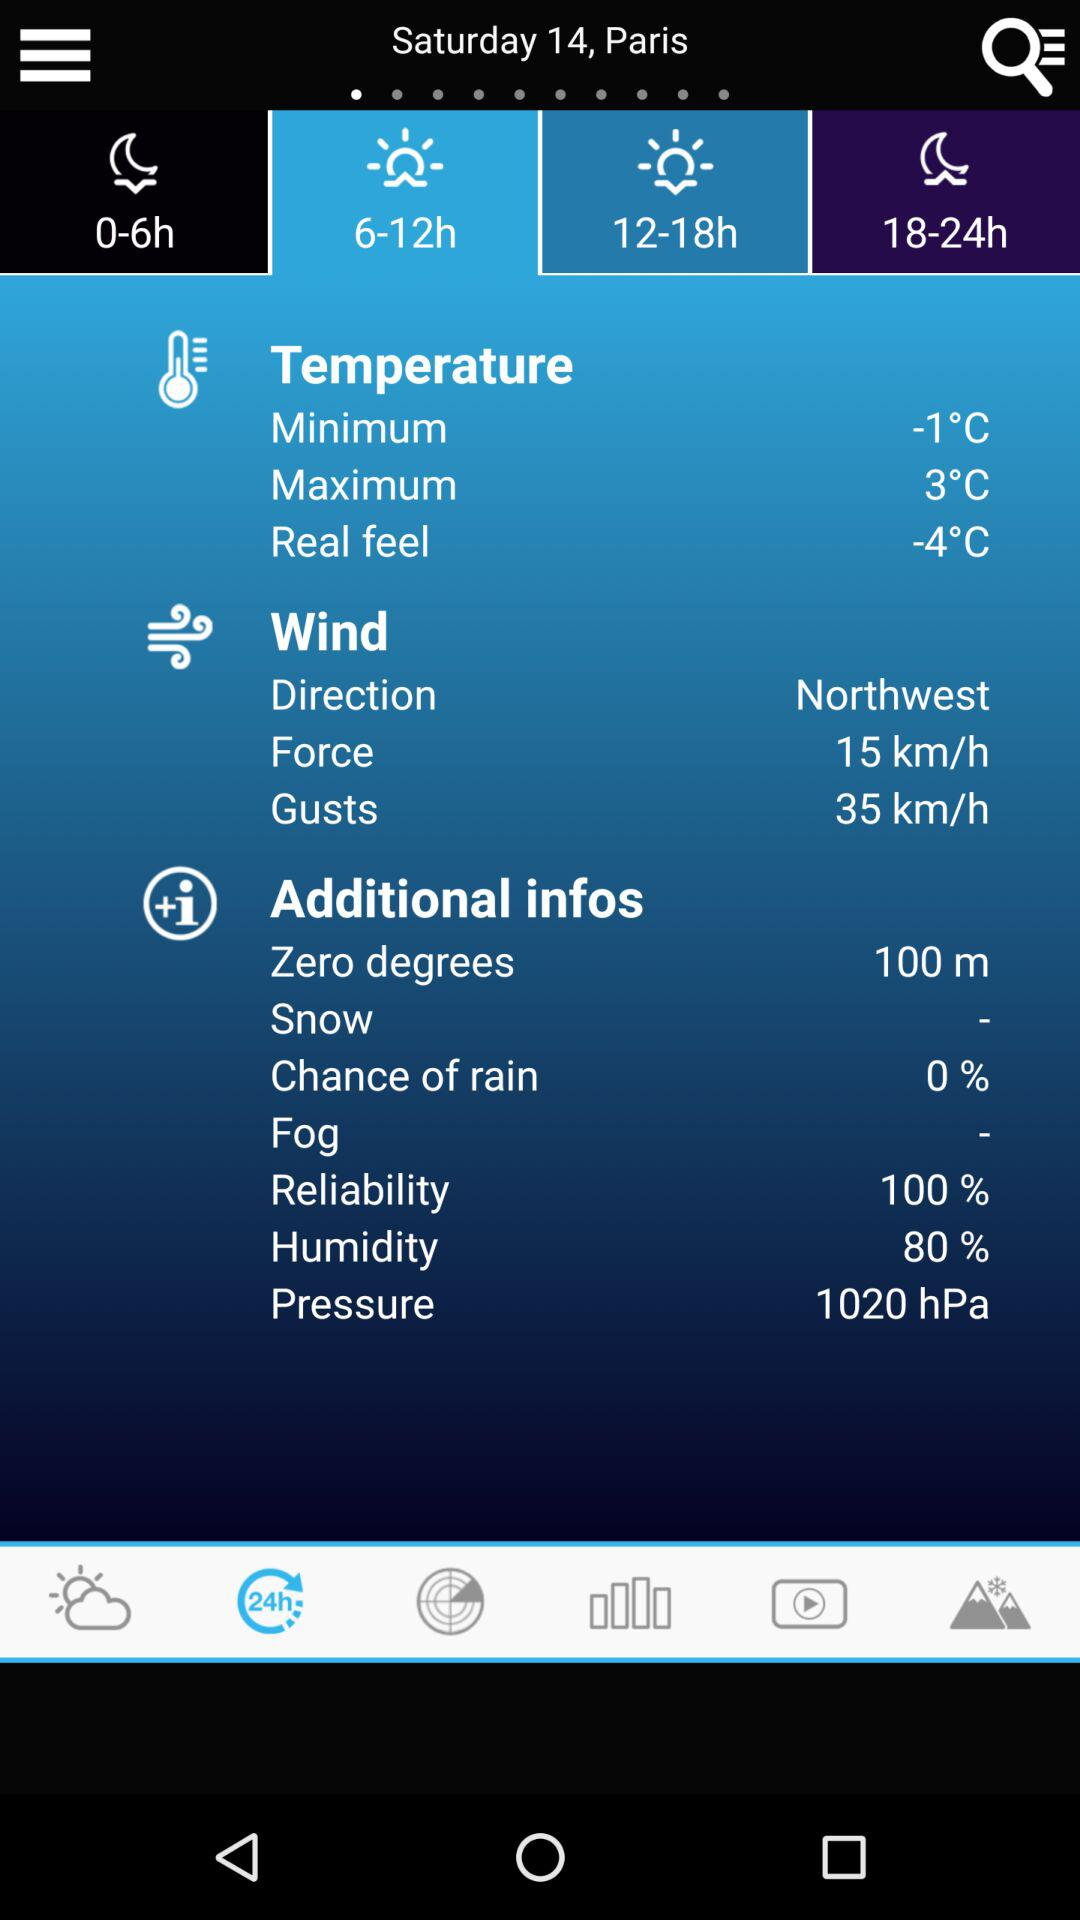What is the wind gust? The wind gust is 35 km/h. 